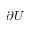Convert formula to latex. <formula><loc_0><loc_0><loc_500><loc_500>\partial U</formula> 